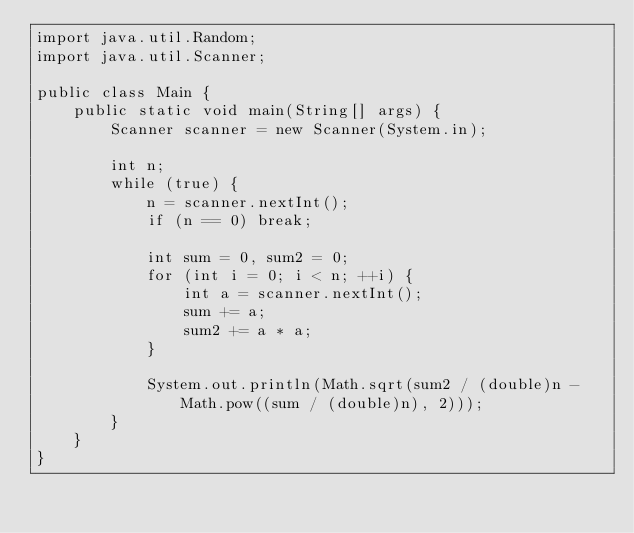<code> <loc_0><loc_0><loc_500><loc_500><_Java_>import java.util.Random;
import java.util.Scanner;

public class Main {
    public static void main(String[] args) {
        Scanner scanner = new Scanner(System.in);

        int n;
        while (true) {
            n = scanner.nextInt();
            if (n == 0) break;

            int sum = 0, sum2 = 0;
            for (int i = 0; i < n; ++i) {
                int a = scanner.nextInt();
                sum += a;
                sum2 += a * a;
            }

            System.out.println(Math.sqrt(sum2 / (double)n - Math.pow((sum / (double)n), 2)));
        }
    }
}

</code> 